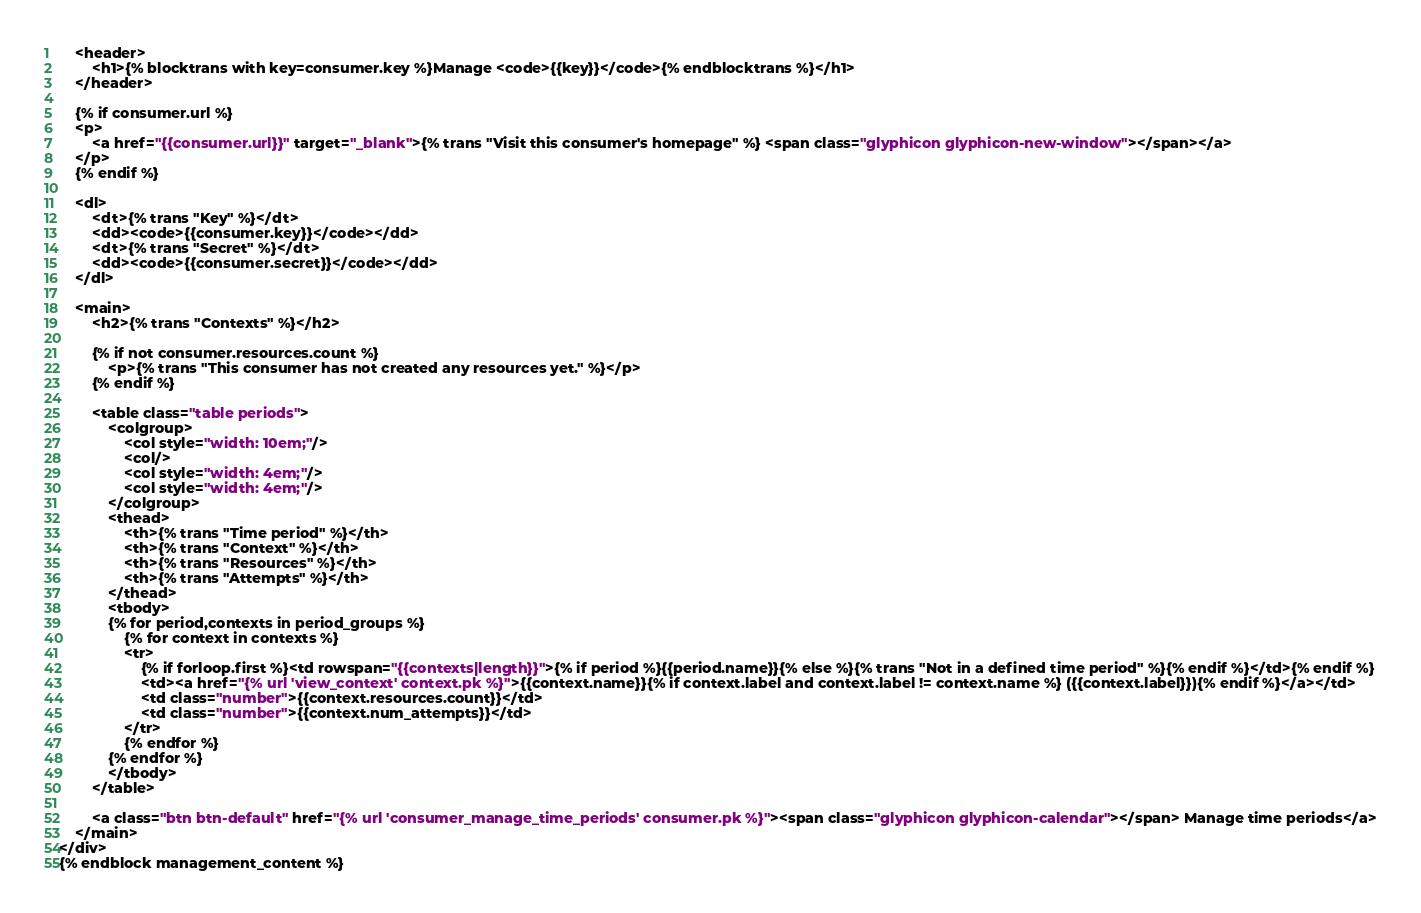Convert code to text. <code><loc_0><loc_0><loc_500><loc_500><_HTML_>    <header>
        <h1>{% blocktrans with key=consumer.key %}Manage <code>{{key}}</code>{% endblocktrans %}</h1>
    </header>

    {% if consumer.url %}
    <p>
        <a href="{{consumer.url}}" target="_blank">{% trans "Visit this consumer's homepage" %} <span class="glyphicon glyphicon-new-window"></span></a>
    </p>
    {% endif %}

    <dl>
        <dt>{% trans "Key" %}</dt>
        <dd><code>{{consumer.key}}</code></dd>
        <dt>{% trans "Secret" %}</dt>
        <dd><code>{{consumer.secret}}</code></dd>
    </dl>

    <main>
        <h2>{% trans "Contexts" %}</h2>

        {% if not consumer.resources.count %}
            <p>{% trans "This consumer has not created any resources yet." %}</p>
        {% endif %}

        <table class="table periods">
            <colgroup>
                <col style="width: 10em;"/>
                <col/>
                <col style="width: 4em;"/>
                <col style="width: 4em;"/>
            </colgroup>
            <thead>
                <th>{% trans "Time period" %}</th>
                <th>{% trans "Context" %}</th>
                <th>{% trans "Resources" %}</th>
                <th>{% trans "Attempts" %}</th>
            </thead>
            <tbody>
            {% for period,contexts in period_groups %}
                {% for context in contexts %}
                <tr>
                    {% if forloop.first %}<td rowspan="{{contexts|length}}">{% if period %}{{period.name}}{% else %}{% trans "Not in a defined time period" %}{% endif %}</td>{% endif %}
                    <td><a href="{% url 'view_context' context.pk %}">{{context.name}}{% if context.label and context.label != context.name %} ({{context.label}}){% endif %}</a></td>
                    <td class="number">{{context.resources.count}}</td>
                    <td class="number">{{context.num_attempts}}</td>
                </tr>
                {% endfor %}
            {% endfor %}
            </tbody>
        </table>

        <a class="btn btn-default" href="{% url 'consumer_manage_time_periods' consumer.pk %}"><span class="glyphicon glyphicon-calendar"></span> Manage time periods</a>
    </main>
</div>
{% endblock management_content %}
</code> 